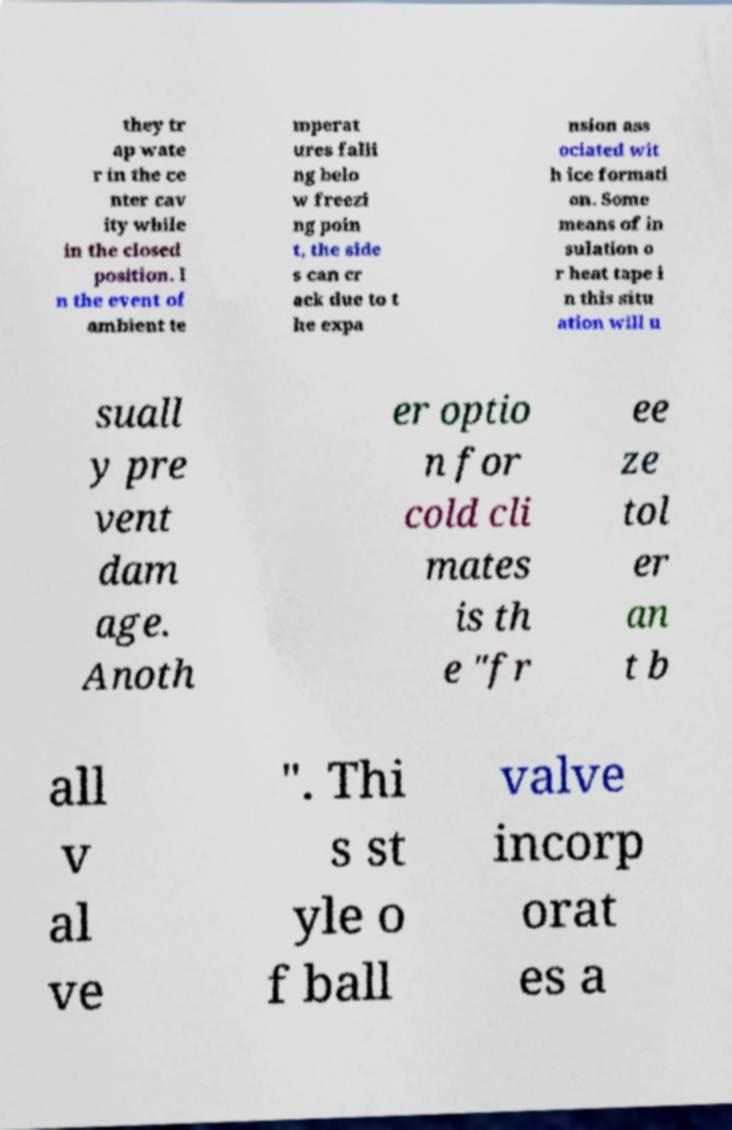Can you read and provide the text displayed in the image?This photo seems to have some interesting text. Can you extract and type it out for me? they tr ap wate r in the ce nter cav ity while in the closed position. I n the event of ambient te mperat ures falli ng belo w freezi ng poin t, the side s can cr ack due to t he expa nsion ass ociated wit h ice formati on. Some means of in sulation o r heat tape i n this situ ation will u suall y pre vent dam age. Anoth er optio n for cold cli mates is th e "fr ee ze tol er an t b all v al ve ". Thi s st yle o f ball valve incorp orat es a 